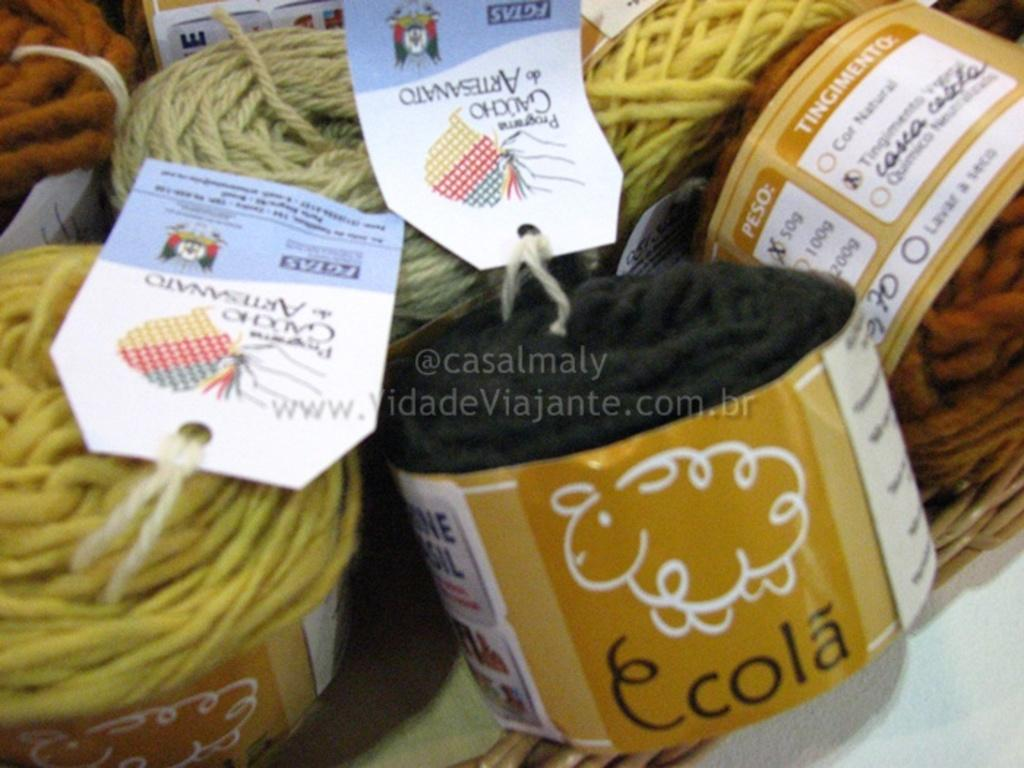What type of material is present in the image? There are yarns in the image. How are the yarns organized or stored in the image? The yarns are placed in a basket. Are there any additional features associated with the yarns in the image? Yes, there are tags associated with the yarns. What type of song is being sung by the coach on the hill in the image? There is no coach or hill present in the image, and therefore no such activity can be observed. 